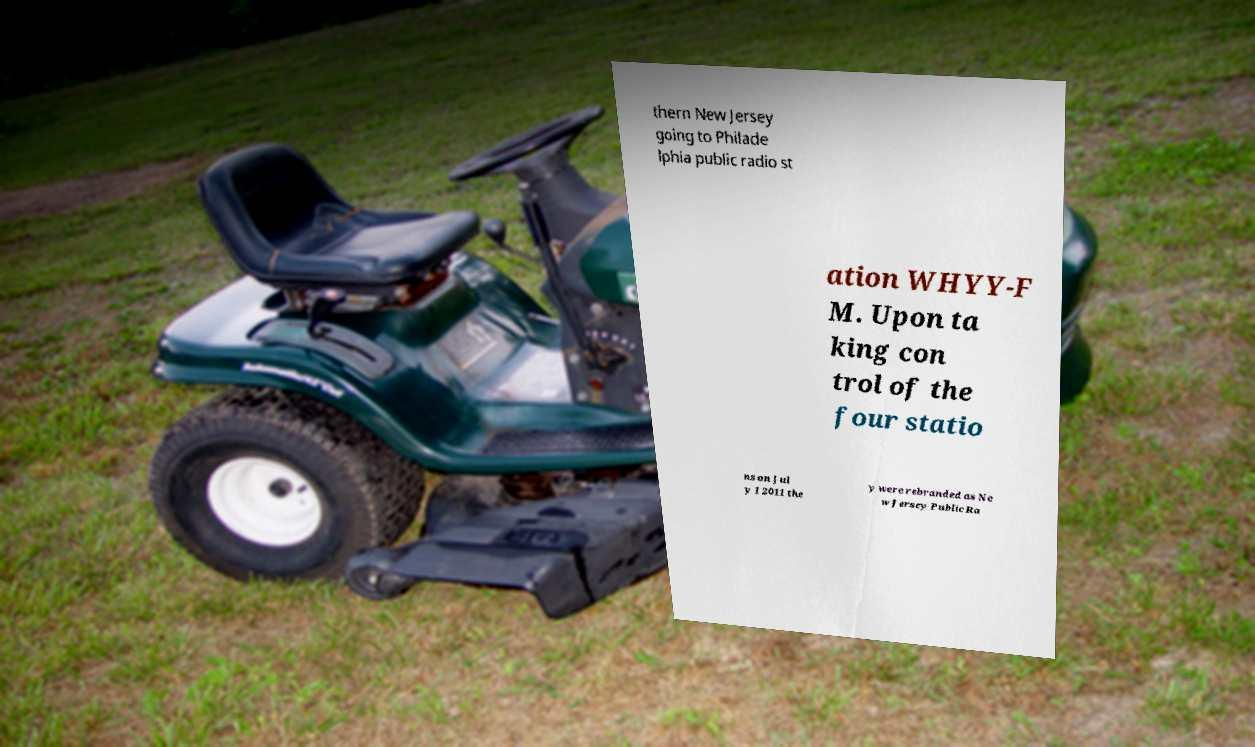There's text embedded in this image that I need extracted. Can you transcribe it verbatim? thern New Jersey going to Philade lphia public radio st ation WHYY-F M. Upon ta king con trol of the four statio ns on Jul y 1 2011 the y were rebranded as Ne w Jersey Public Ra 